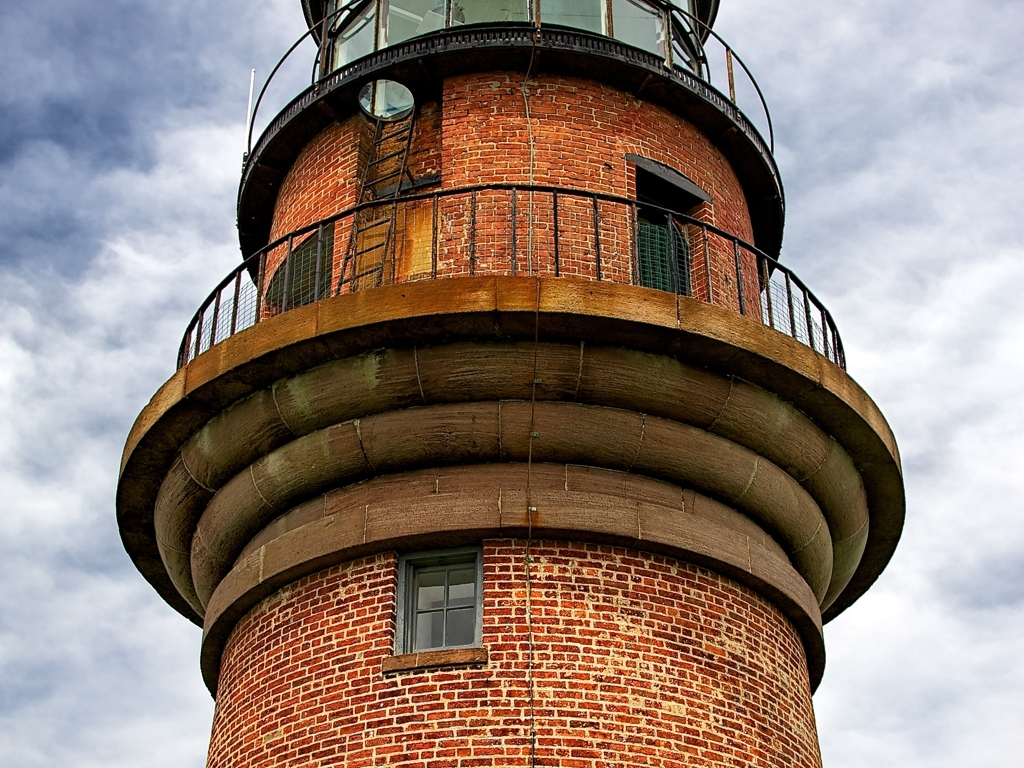What kind of architectural style is reflected in this lighthouse? The lighthouse exhibits characteristics of utilitarian maritime architecture, with a focus on robustness and durability. The brickwork suggests a late 19th or early 20th-century design, typical of the era's industrial brick constructions. The rusticated stone base and the metal detailing at the gallery deck implies a mix of craftsmanship and industrial efficiency, aiming to withstand harsh weather conditions. 